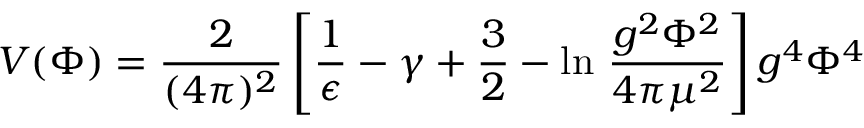<formula> <loc_0><loc_0><loc_500><loc_500>V ( \Phi ) = \frac { 2 } { ( 4 \pi ) ^ { 2 } } \left [ \frac { 1 } { \epsilon } - \gamma + \frac { 3 } { 2 } - \ln \, \frac { g ^ { 2 } \Phi ^ { 2 } } { 4 \pi \mu ^ { 2 } } \right ] g ^ { 4 } \Phi ^ { 4 }</formula> 